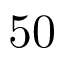<formula> <loc_0><loc_0><loc_500><loc_500>5 0</formula> 